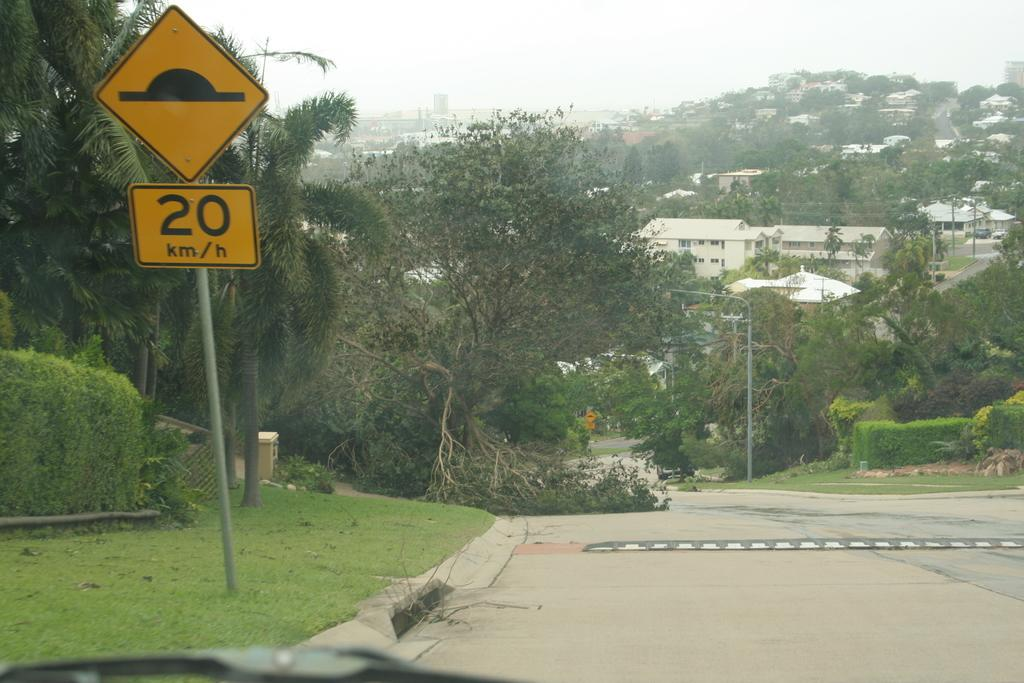What can be seen on the sign boards in the image? The content of the sign boards cannot be determined from the image. What type of vegetation is visible in the image? There is grass visible in the image, and there are also trees. What can be seen in the background of the image? In the background of the image, there are poles and buildings. What type of paper is being used to produce the sign boards in the image? There is no indication of the material used for the sign boards in the image. 